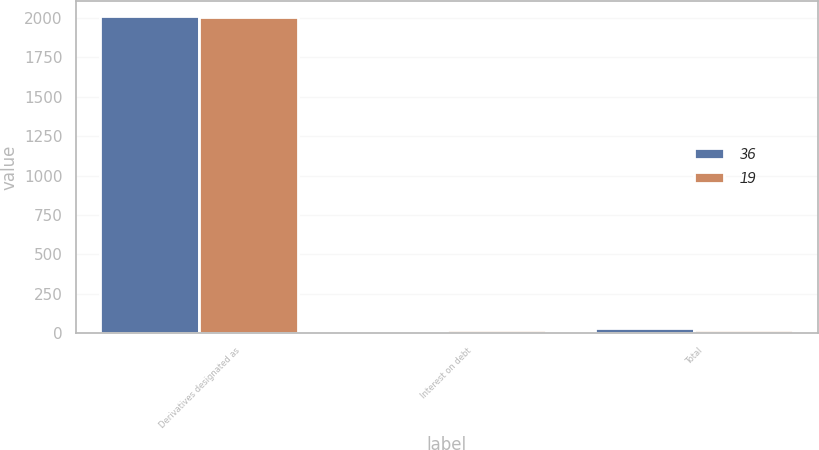Convert chart. <chart><loc_0><loc_0><loc_500><loc_500><stacked_bar_chart><ecel><fcel>Derivatives designated as<fcel>Interest on debt<fcel>Total<nl><fcel>36<fcel>2010<fcel>16<fcel>36<nl><fcel>19<fcel>2009<fcel>19<fcel>19<nl></chart> 